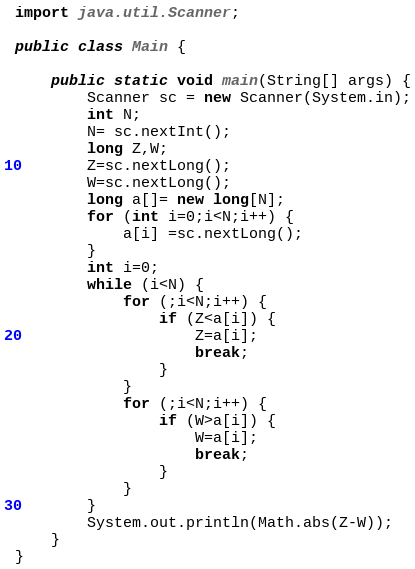<code> <loc_0><loc_0><loc_500><loc_500><_Java_>import java.util.Scanner;

public class Main {

	public static void main(String[] args) {
		Scanner sc = new Scanner(System.in);
		int N;
		N= sc.nextInt();
		long Z,W;
		Z=sc.nextLong();
		W=sc.nextLong();
		long a[]= new long[N];
		for (int i=0;i<N;i++) {
			a[i] =sc.nextLong();
		}
		int i=0;
		while (i<N) {
			for (;i<N;i++) {
				if (Z<a[i]) {
					Z=a[i];
					break;
				}
			}
			for (;i<N;i++) {
				if (W>a[i]) {
					W=a[i];
					break;
				}
			}
		}
		System.out.println(Math.abs(Z-W));
 	}
}</code> 